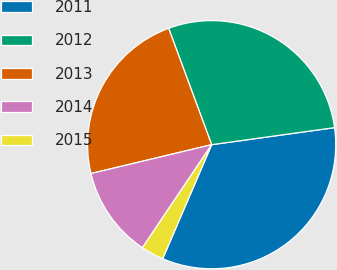Convert chart. <chart><loc_0><loc_0><loc_500><loc_500><pie_chart><fcel>2011<fcel>2012<fcel>2013<fcel>2014<fcel>2015<nl><fcel>33.65%<fcel>28.44%<fcel>23.1%<fcel>11.85%<fcel>2.96%<nl></chart> 